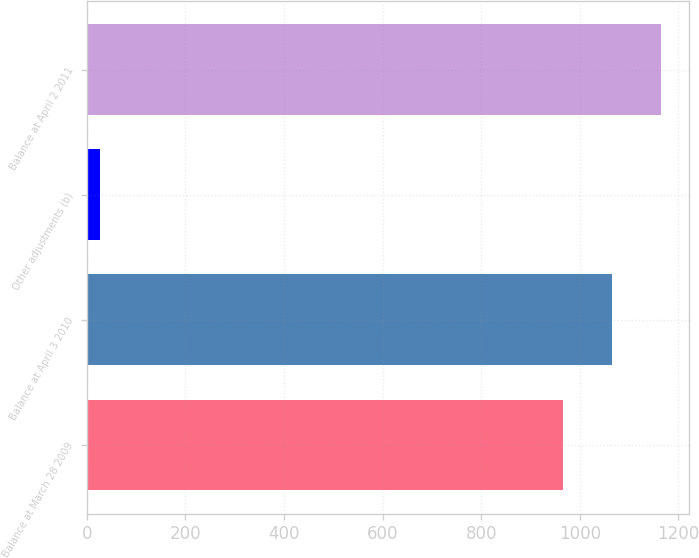<chart> <loc_0><loc_0><loc_500><loc_500><bar_chart><fcel>Balance at March 28 2009<fcel>Balance at April 3 2010<fcel>Other adjustments (b)<fcel>Balance at April 2 2011<nl><fcel>966.4<fcel>1065.44<fcel>25.9<fcel>1164.48<nl></chart> 